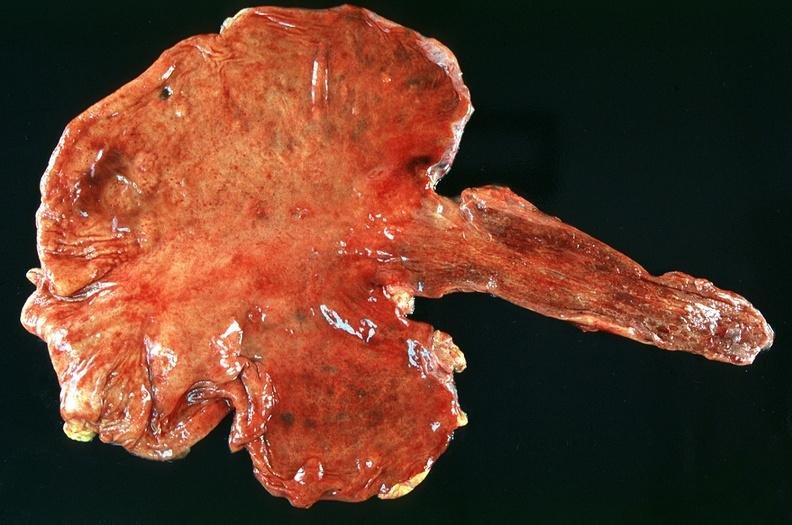does this image show stomach, ulcerations and hemorrhages nosogastric tube?
Answer the question using a single word or phrase. Yes 